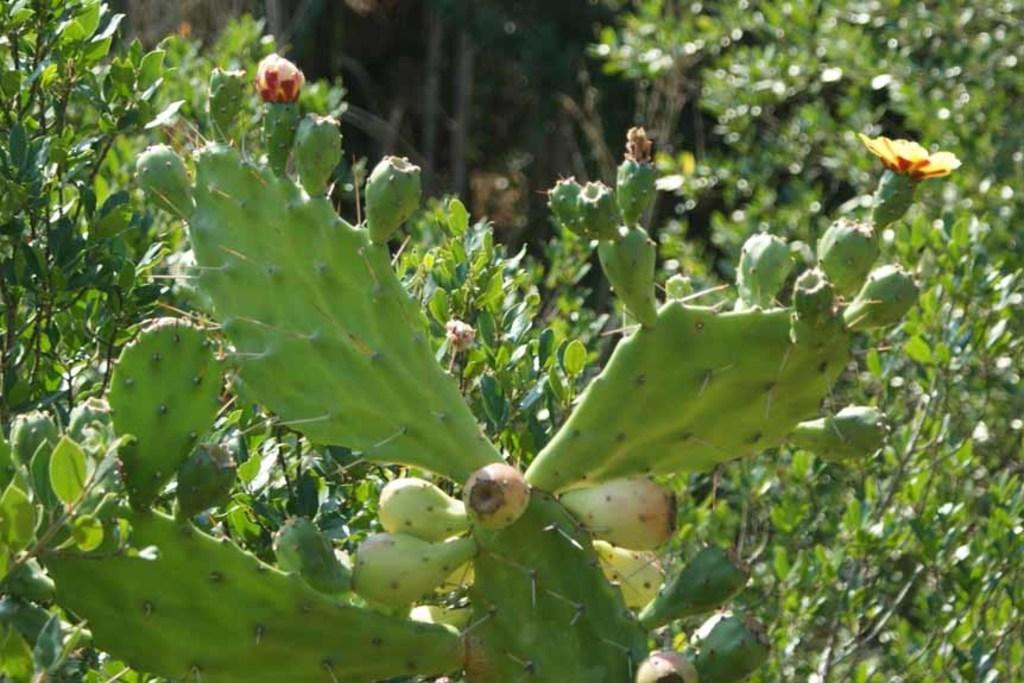What type of plant is featured in the image? There is a cactus plant with flowers in the image. What can be seen in the background of the image? There are trees in the background of the image. Is there a beggar playing a drum in the image? No, there is no beggar or drum present in the image. The image features a cactus plant with flowers and trees in the background. 